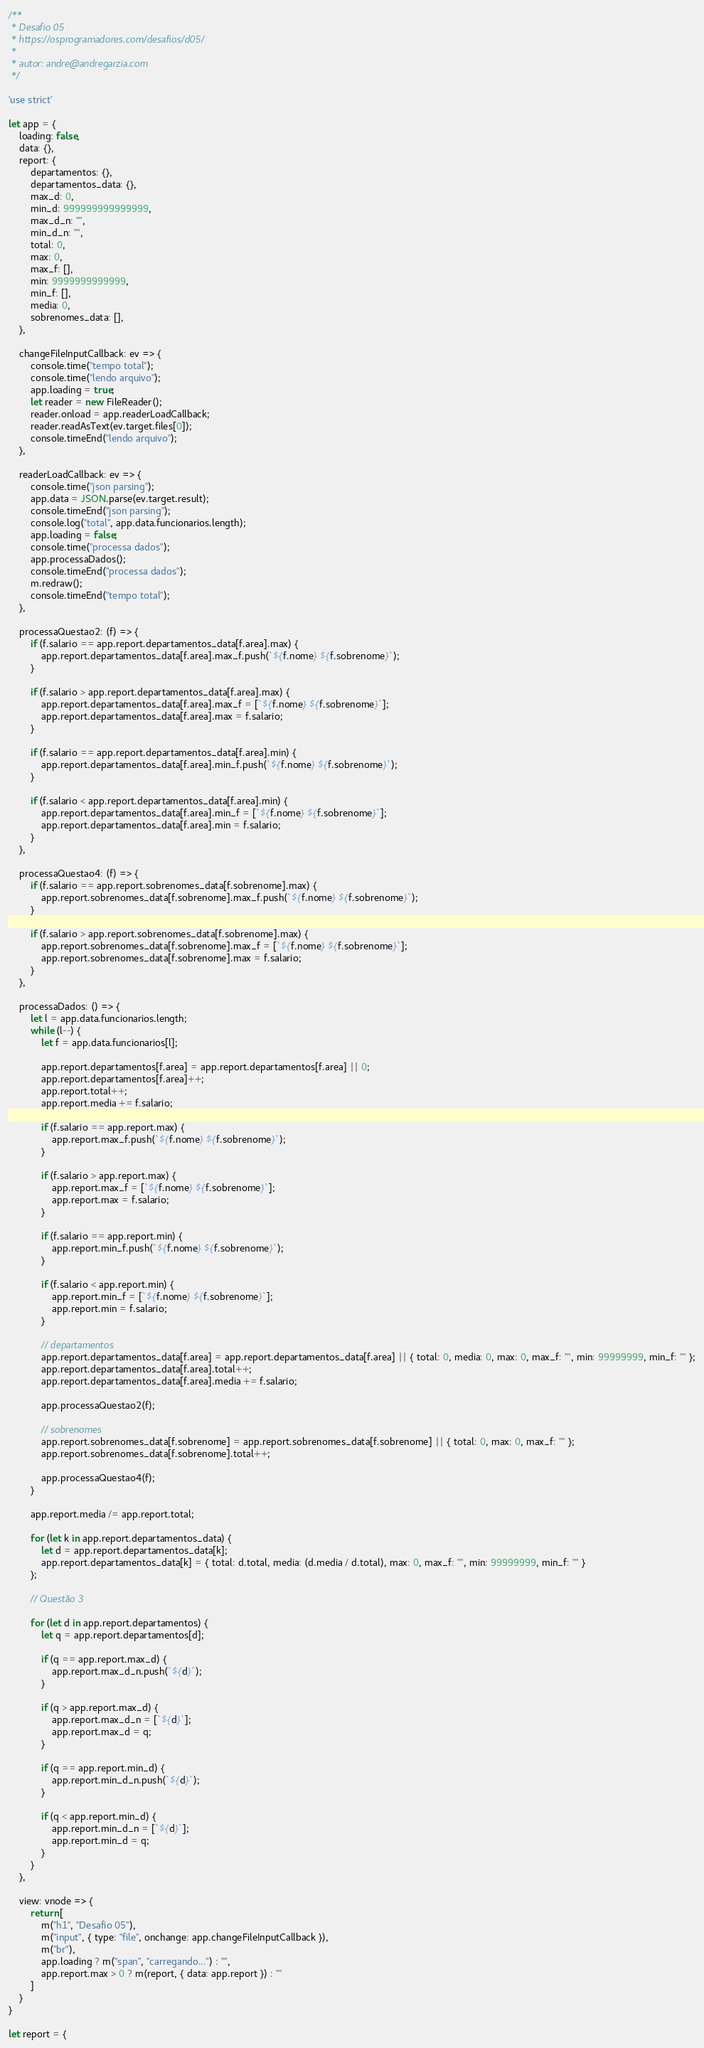Convert code to text. <code><loc_0><loc_0><loc_500><loc_500><_JavaScript_>/**
 * Desafio 05
 * https://osprogramadores.com/desafios/d05/
 * 
 * autor: andre@andregarzia.com
 */

'use strict'

let app = {
    loading: false,
    data: {},
    report: {
        departamentos: {},
        departamentos_data: {},
        max_d: 0,
        min_d: 999999999999999,
        max_d_n: "",
        min_d_n: "",
        total: 0,
        max: 0,
        max_f: [],
        min: 9999999999999,
        min_f: [],
        media: 0,
        sobrenomes_data: [],
    },

    changeFileInputCallback: ev => {
        console.time("tempo total");
        console.time("lendo arquivo");
        app.loading = true;
        let reader = new FileReader();
        reader.onload = app.readerLoadCallback;
        reader.readAsText(ev.target.files[0]);
        console.timeEnd("lendo arquivo");
    },

    readerLoadCallback: ev => {
        console.time("json parsing");
        app.data = JSON.parse(ev.target.result);
        console.timeEnd("json parsing");
        console.log("total", app.data.funcionarios.length);
        app.loading = false;
        console.time("processa dados");
        app.processaDados();
        console.timeEnd("processa dados");
        m.redraw();
        console.timeEnd("tempo total");
    },

    processaQuestao2: (f) => {
        if (f.salario == app.report.departamentos_data[f.area].max) {
            app.report.departamentos_data[f.area].max_f.push(`${f.nome} ${f.sobrenome}`);
        }

        if (f.salario > app.report.departamentos_data[f.area].max) {
            app.report.departamentos_data[f.area].max_f = [`${f.nome} ${f.sobrenome}`];
            app.report.departamentos_data[f.area].max = f.salario;
        }

        if (f.salario == app.report.departamentos_data[f.area].min) {
            app.report.departamentos_data[f.area].min_f.push(`${f.nome} ${f.sobrenome}`);
        }

        if (f.salario < app.report.departamentos_data[f.area].min) {
            app.report.departamentos_data[f.area].min_f = [`${f.nome} ${f.sobrenome}`];
            app.report.departamentos_data[f.area].min = f.salario;
        }
    },

    processaQuestao4: (f) => {
        if (f.salario == app.report.sobrenomes_data[f.sobrenome].max) {
            app.report.sobrenomes_data[f.sobrenome].max_f.push(`${f.nome} ${f.sobrenome}`);
        }

        if (f.salario > app.report.sobrenomes_data[f.sobrenome].max) {
            app.report.sobrenomes_data[f.sobrenome].max_f = [`${f.nome} ${f.sobrenome}`];
            app.report.sobrenomes_data[f.sobrenome].max = f.salario;
        }
    },

    processaDados: () => {
        let l = app.data.funcionarios.length;
        while (l--) {
            let f = app.data.funcionarios[l];

            app.report.departamentos[f.area] = app.report.departamentos[f.area] || 0;
            app.report.departamentos[f.area]++;
            app.report.total++;
            app.report.media += f.salario;

            if (f.salario == app.report.max) {
                app.report.max_f.push(`${f.nome} ${f.sobrenome}`);
            }

            if (f.salario > app.report.max) {
                app.report.max_f = [`${f.nome} ${f.sobrenome}`];
                app.report.max = f.salario;
            }

            if (f.salario == app.report.min) {
                app.report.min_f.push(`${f.nome} ${f.sobrenome}`);
            }

            if (f.salario < app.report.min) {
                app.report.min_f = [`${f.nome} ${f.sobrenome}`];
                app.report.min = f.salario;
            }

            // departamentos
            app.report.departamentos_data[f.area] = app.report.departamentos_data[f.area] || { total: 0, media: 0, max: 0, max_f: "", min: 99999999, min_f: "" };
            app.report.departamentos_data[f.area].total++;
            app.report.departamentos_data[f.area].media += f.salario;

            app.processaQuestao2(f);

            // sobrenomes
            app.report.sobrenomes_data[f.sobrenome] = app.report.sobrenomes_data[f.sobrenome] || { total: 0, max: 0, max_f: "" };
            app.report.sobrenomes_data[f.sobrenome].total++;

            app.processaQuestao4(f);
        }

        app.report.media /= app.report.total;

        for (let k in app.report.departamentos_data) {
            let d = app.report.departamentos_data[k];
            app.report.departamentos_data[k] = { total: d.total, media: (d.media / d.total), max: 0, max_f: "", min: 99999999, min_f: "" }
        };

        // Questão 3

        for (let d in app.report.departamentos) {
            let q = app.report.departamentos[d];

            if (q == app.report.max_d) {
                app.report.max_d_n.push(`${d}`);
            }

            if (q > app.report.max_d) {
                app.report.max_d_n = [`${d}`];
                app.report.max_d = q;
            }

            if (q == app.report.min_d) {
                app.report.min_d_n.push(`${d}`);
            }

            if (q < app.report.min_d) {
                app.report.min_d_n = [`${d}`];
                app.report.min_d = q;
            }
        }
    },

    view: vnode => {
        return [
            m("h1", "Desafio 05"),
            m("input", { type: "file", onchange: app.changeFileInputCallback }),
            m("br"),
            app.loading ? m("span", "carregando...") : "",
            app.report.max > 0 ? m(report, { data: app.report }) : ""
        ]
    }
}

let report = {</code> 